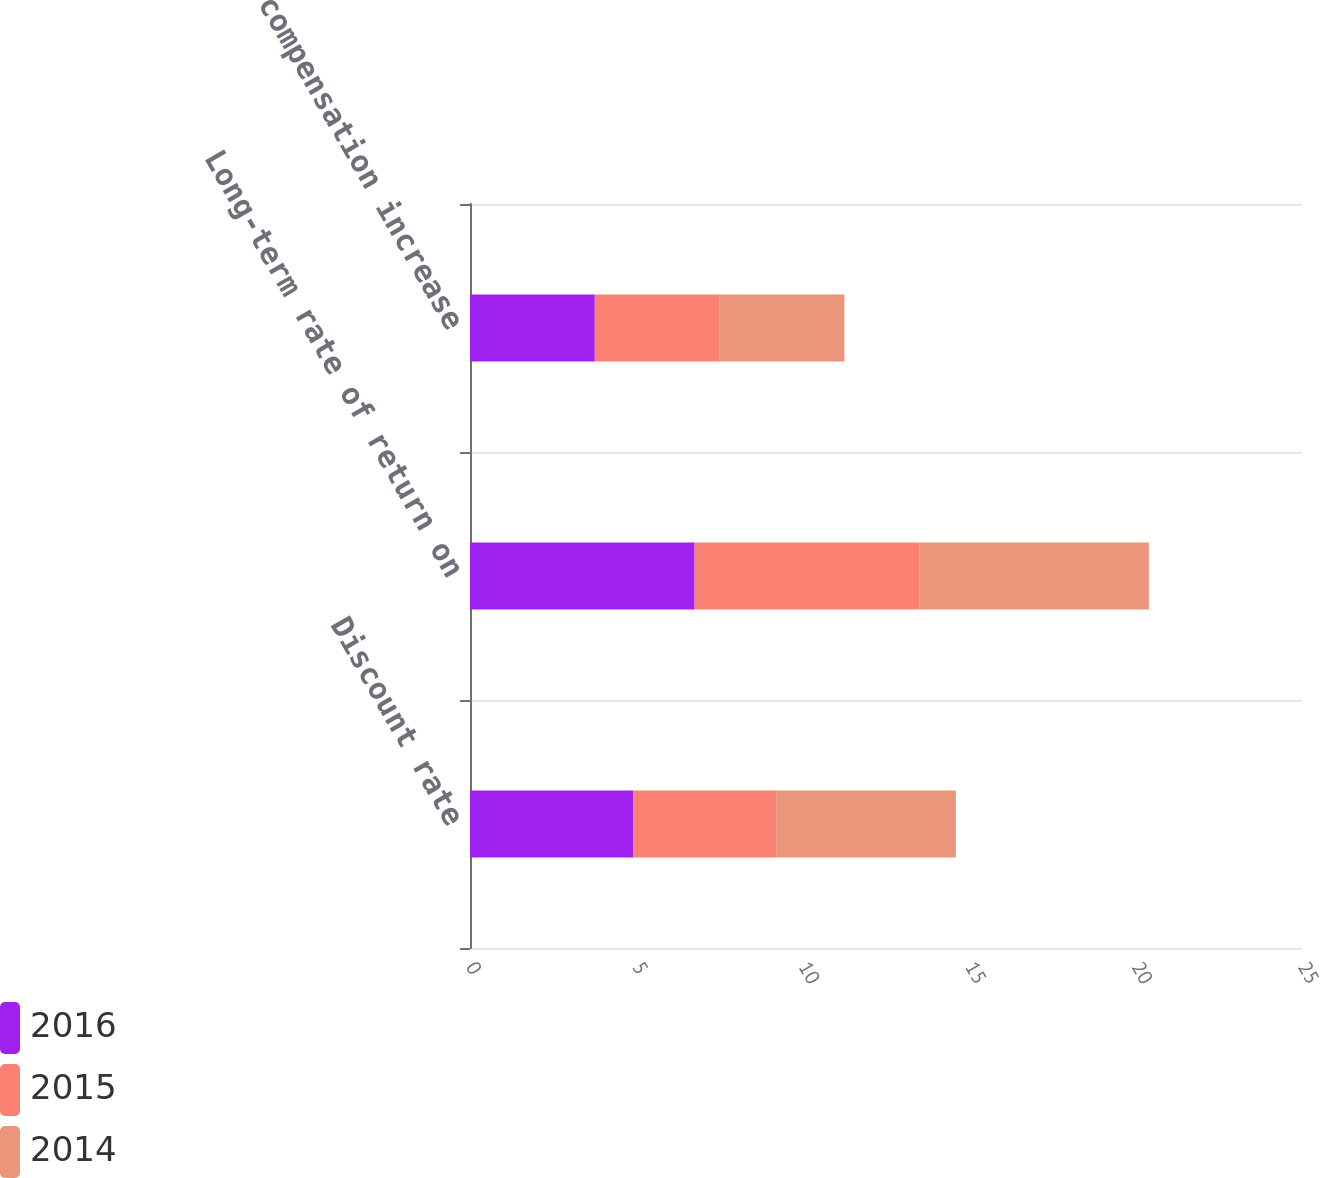<chart> <loc_0><loc_0><loc_500><loc_500><stacked_bar_chart><ecel><fcel>Discount rate<fcel>Long-term rate of return on<fcel>Rate of compensation increase<nl><fcel>2016<fcel>4.9<fcel>6.75<fcel>3.75<nl><fcel>2015<fcel>4.3<fcel>6.75<fcel>3.75<nl><fcel>2014<fcel>5.4<fcel>6.9<fcel>3.75<nl></chart> 